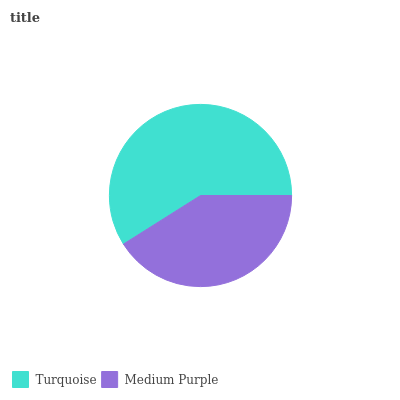Is Medium Purple the minimum?
Answer yes or no. Yes. Is Turquoise the maximum?
Answer yes or no. Yes. Is Medium Purple the maximum?
Answer yes or no. No. Is Turquoise greater than Medium Purple?
Answer yes or no. Yes. Is Medium Purple less than Turquoise?
Answer yes or no. Yes. Is Medium Purple greater than Turquoise?
Answer yes or no. No. Is Turquoise less than Medium Purple?
Answer yes or no. No. Is Turquoise the high median?
Answer yes or no. Yes. Is Medium Purple the low median?
Answer yes or no. Yes. Is Medium Purple the high median?
Answer yes or no. No. Is Turquoise the low median?
Answer yes or no. No. 